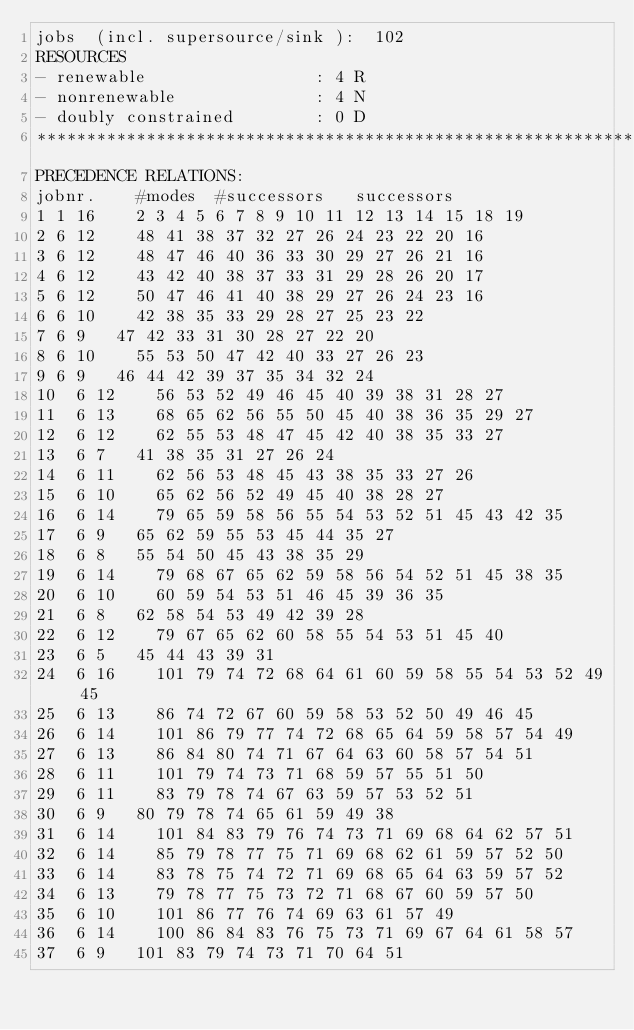Convert code to text. <code><loc_0><loc_0><loc_500><loc_500><_ObjectiveC_>jobs  (incl. supersource/sink ):	102
RESOURCES
- renewable                 : 4 R
- nonrenewable              : 4 N
- doubly constrained        : 0 D
************************************************************************
PRECEDENCE RELATIONS:
jobnr.    #modes  #successors   successors
1	1	16		2 3 4 5 6 7 8 9 10 11 12 13 14 15 18 19 
2	6	12		48 41 38 37 32 27 26 24 23 22 20 16 
3	6	12		48 47 46 40 36 33 30 29 27 26 21 16 
4	6	12		43 42 40 38 37 33 31 29 28 26 20 17 
5	6	12		50 47 46 41 40 38 29 27 26 24 23 16 
6	6	10		42 38 35 33 29 28 27 25 23 22 
7	6	9		47 42 33 31 30 28 27 22 20 
8	6	10		55 53 50 47 42 40 33 27 26 23 
9	6	9		46 44 42 39 37 35 34 32 24 
10	6	12		56 53 52 49 46 45 40 39 38 31 28 27 
11	6	13		68 65 62 56 55 50 45 40 38 36 35 29 27 
12	6	12		62 55 53 48 47 45 42 40 38 35 33 27 
13	6	7		41 38 35 31 27 26 24 
14	6	11		62 56 53 48 45 43 38 35 33 27 26 
15	6	10		65 62 56 52 49 45 40 38 28 27 
16	6	14		79 65 59 58 56 55 54 53 52 51 45 43 42 35 
17	6	9		65 62 59 55 53 45 44 35 27 
18	6	8		55 54 50 45 43 38 35 29 
19	6	14		79 68 67 65 62 59 58 56 54 52 51 45 38 35 
20	6	10		60 59 54 53 51 46 45 39 36 35 
21	6	8		62 58 54 53 49 42 39 28 
22	6	12		79 67 65 62 60 58 55 54 53 51 45 40 
23	6	5		45 44 43 39 31 
24	6	16		101 79 74 72 68 64 61 60 59 58 55 54 53 52 49 45 
25	6	13		86 74 72 67 60 59 58 53 52 50 49 46 45 
26	6	14		101 86 79 77 74 72 68 65 64 59 58 57 54 49 
27	6	13		86 84 80 74 71 67 64 63 60 58 57 54 51 
28	6	11		101 79 74 73 71 68 59 57 55 51 50 
29	6	11		83 79 78 74 67 63 59 57 53 52 51 
30	6	9		80 79 78 74 65 61 59 49 38 
31	6	14		101 84 83 79 76 74 73 71 69 68 64 62 57 51 
32	6	14		85 79 78 77 75 71 69 68 62 61 59 57 52 50 
33	6	14		83 78 75 74 72 71 69 68 65 64 63 59 57 52 
34	6	13		79 78 77 75 73 72 71 68 67 60 59 57 50 
35	6	10		101 86 77 76 74 69 63 61 57 49 
36	6	14		100 86 84 83 76 75 73 71 69 67 64 61 58 57 
37	6	9		101 83 79 74 73 71 70 64 51 </code> 